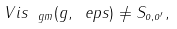Convert formula to latex. <formula><loc_0><loc_0><loc_500><loc_500>\ V i s _ { \ g m } ( g , \ e p s ) \neq S _ { o , o ^ { \prime } } ,</formula> 